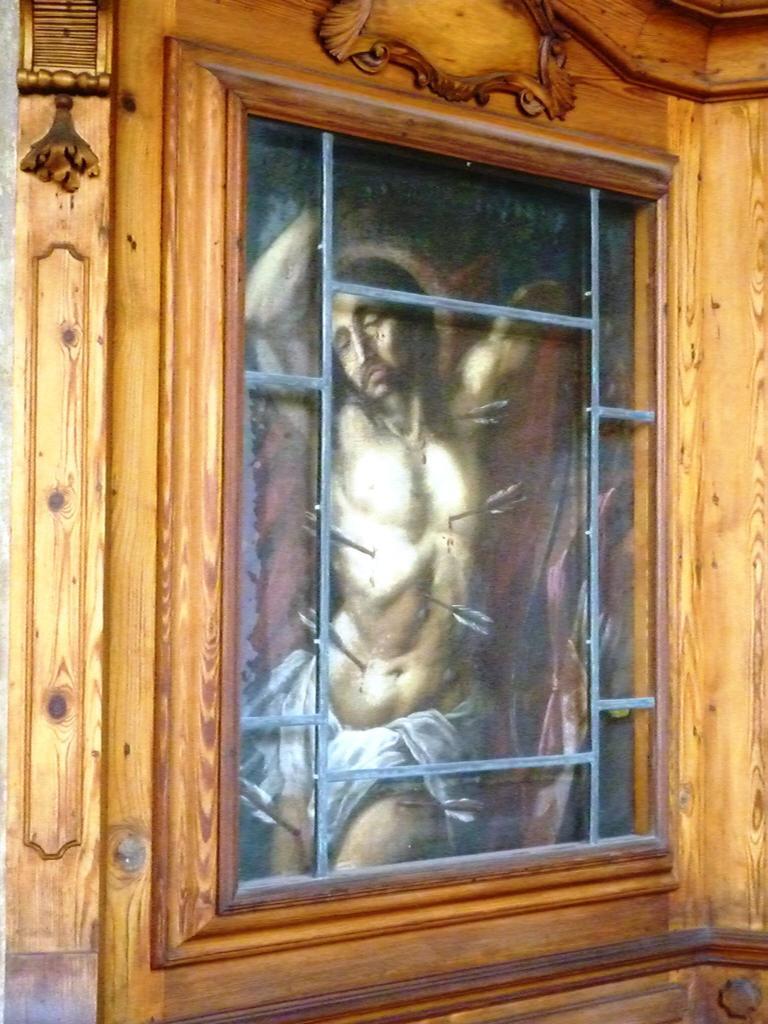Describe this image in one or two sentences. In this image I can see the brown colored wooden structure around the photograph and in the photo I can see a person wearing the white colored cloth. 